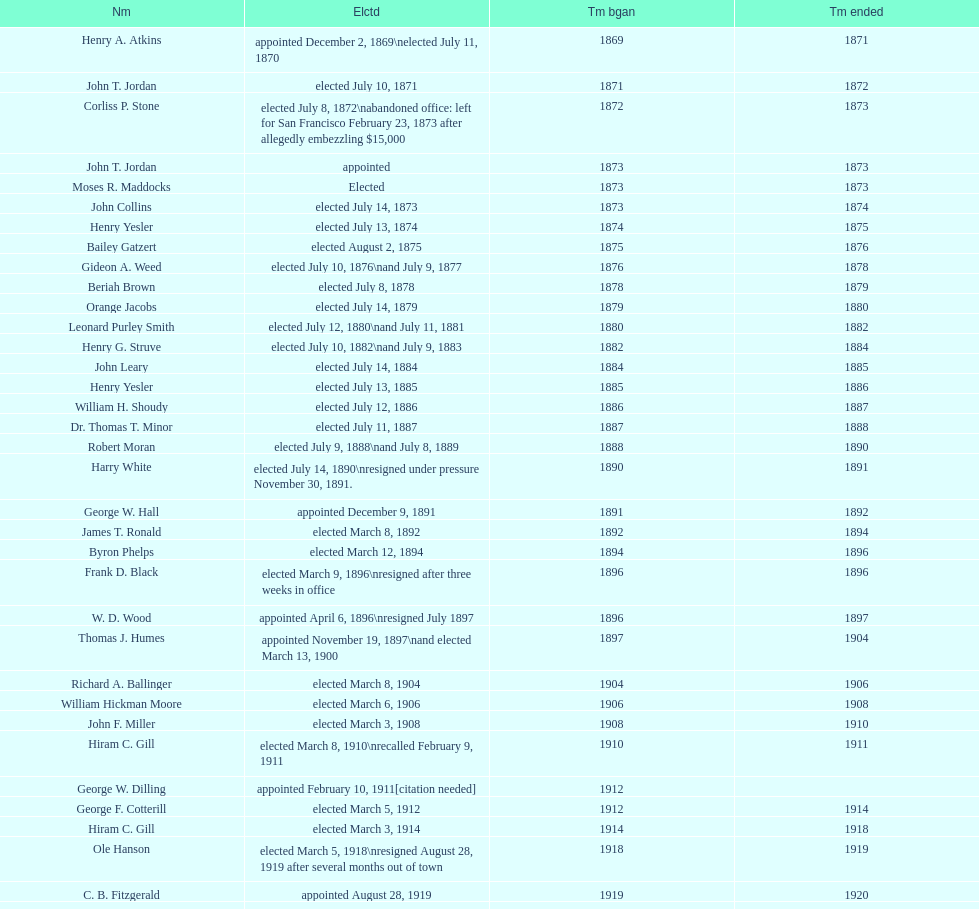Who was the first mayor in the 1900's? Richard A. Ballinger. Would you be able to parse every entry in this table? {'header': ['Nm', 'Elctd', 'Tm bgan', 'Tm ended'], 'rows': [['Henry A. Atkins', 'appointed December 2, 1869\\nelected July 11, 1870', '1869', '1871'], ['John T. Jordan', 'elected July 10, 1871', '1871', '1872'], ['Corliss P. Stone', 'elected July 8, 1872\\nabandoned office: left for San Francisco February 23, 1873 after allegedly embezzling $15,000', '1872', '1873'], ['John T. Jordan', 'appointed', '1873', '1873'], ['Moses R. Maddocks', 'Elected', '1873', '1873'], ['John Collins', 'elected July 14, 1873', '1873', '1874'], ['Henry Yesler', 'elected July 13, 1874', '1874', '1875'], ['Bailey Gatzert', 'elected August 2, 1875', '1875', '1876'], ['Gideon A. Weed', 'elected July 10, 1876\\nand July 9, 1877', '1876', '1878'], ['Beriah Brown', 'elected July 8, 1878', '1878', '1879'], ['Orange Jacobs', 'elected July 14, 1879', '1879', '1880'], ['Leonard Purley Smith', 'elected July 12, 1880\\nand July 11, 1881', '1880', '1882'], ['Henry G. Struve', 'elected July 10, 1882\\nand July 9, 1883', '1882', '1884'], ['John Leary', 'elected July 14, 1884', '1884', '1885'], ['Henry Yesler', 'elected July 13, 1885', '1885', '1886'], ['William H. Shoudy', 'elected July 12, 1886', '1886', '1887'], ['Dr. Thomas T. Minor', 'elected July 11, 1887', '1887', '1888'], ['Robert Moran', 'elected July 9, 1888\\nand July 8, 1889', '1888', '1890'], ['Harry White', 'elected July 14, 1890\\nresigned under pressure November 30, 1891.', '1890', '1891'], ['George W. Hall', 'appointed December 9, 1891', '1891', '1892'], ['James T. Ronald', 'elected March 8, 1892', '1892', '1894'], ['Byron Phelps', 'elected March 12, 1894', '1894', '1896'], ['Frank D. Black', 'elected March 9, 1896\\nresigned after three weeks in office', '1896', '1896'], ['W. D. Wood', 'appointed April 6, 1896\\nresigned July 1897', '1896', '1897'], ['Thomas J. Humes', 'appointed November 19, 1897\\nand elected March 13, 1900', '1897', '1904'], ['Richard A. Ballinger', 'elected March 8, 1904', '1904', '1906'], ['William Hickman Moore', 'elected March 6, 1906', '1906', '1908'], ['John F. Miller', 'elected March 3, 1908', '1908', '1910'], ['Hiram C. Gill', 'elected March 8, 1910\\nrecalled February 9, 1911', '1910', '1911'], ['George W. Dilling', 'appointed February 10, 1911[citation needed]', '1912', ''], ['George F. Cotterill', 'elected March 5, 1912', '1912', '1914'], ['Hiram C. Gill', 'elected March 3, 1914', '1914', '1918'], ['Ole Hanson', 'elected March 5, 1918\\nresigned August 28, 1919 after several months out of town', '1918', '1919'], ['C. B. Fitzgerald', 'appointed August 28, 1919', '1919', '1920'], ['Hugh M. Caldwell', 'elected March 2, 1920', '1920', '1922'], ['Edwin J. Brown', 'elected May 2, 1922\\nand March 4, 1924', '1922', '1926'], ['Bertha Knight Landes', 'elected March 9, 1926', '1926', '1928'], ['Frank E. Edwards', 'elected March 6, 1928\\nand March 4, 1930\\nrecalled July 13, 1931', '1928', '1931'], ['Robert H. Harlin', 'appointed July 14, 1931', '1931', '1932'], ['John F. Dore', 'elected March 8, 1932', '1932', '1934'], ['Charles L. Smith', 'elected March 6, 1934', '1934', '1936'], ['John F. Dore', 'elected March 3, 1936\\nbecame gravely ill and was relieved of office April 13, 1938, already a lame duck after the 1938 election. He died five days later.', '1936', '1938'], ['Arthur B. Langlie', "elected March 8, 1938\\nappointed to take office early, April 27, 1938, after Dore's death.\\nelected March 5, 1940\\nresigned January 11, 1941, to become Governor of Washington", '1938', '1941'], ['John E. Carroll', 'appointed January 27, 1941', '1941', '1941'], ['Earl Millikin', 'elected March 4, 1941', '1941', '1942'], ['William F. Devin', 'elected March 3, 1942, March 7, 1944, March 5, 1946, and March 2, 1948', '1942', '1952'], ['Allan Pomeroy', 'elected March 4, 1952', '1952', '1956'], ['Gordon S. Clinton', 'elected March 6, 1956\\nand March 8, 1960', '1956', '1964'], ["James d'Orma Braman", 'elected March 10, 1964\\nresigned March 23, 1969, to accept an appointment as an Assistant Secretary in the Department of Transportation in the Nixon administration.', '1964', '1969'], ['Floyd C. Miller', 'appointed March 23, 1969', '1969', '1969'], ['Wesley C. Uhlman', 'elected November 4, 1969\\nand November 6, 1973\\nsurvived recall attempt on July 1, 1975', 'December 1, 1969', 'January 1, 1978'], ['Charles Royer', 'elected November 8, 1977, November 3, 1981, and November 5, 1985', 'January 1, 1978', 'January 1, 1990'], ['Norman B. Rice', 'elected November 7, 1989', 'January 1, 1990', 'January 1, 1998'], ['Paul Schell', 'elected November 4, 1997', 'January 1, 1998', 'January 1, 2002'], ['Gregory J. Nickels', 'elected November 6, 2001\\nand November 8, 2005', 'January 1, 2002', 'January 1, 2010'], ['Michael McGinn', 'elected November 3, 2009', 'January 1, 2010', 'January 1, 2014'], ['Ed Murray', 'elected November 5, 2013', 'January 1, 2014', 'present']]} 